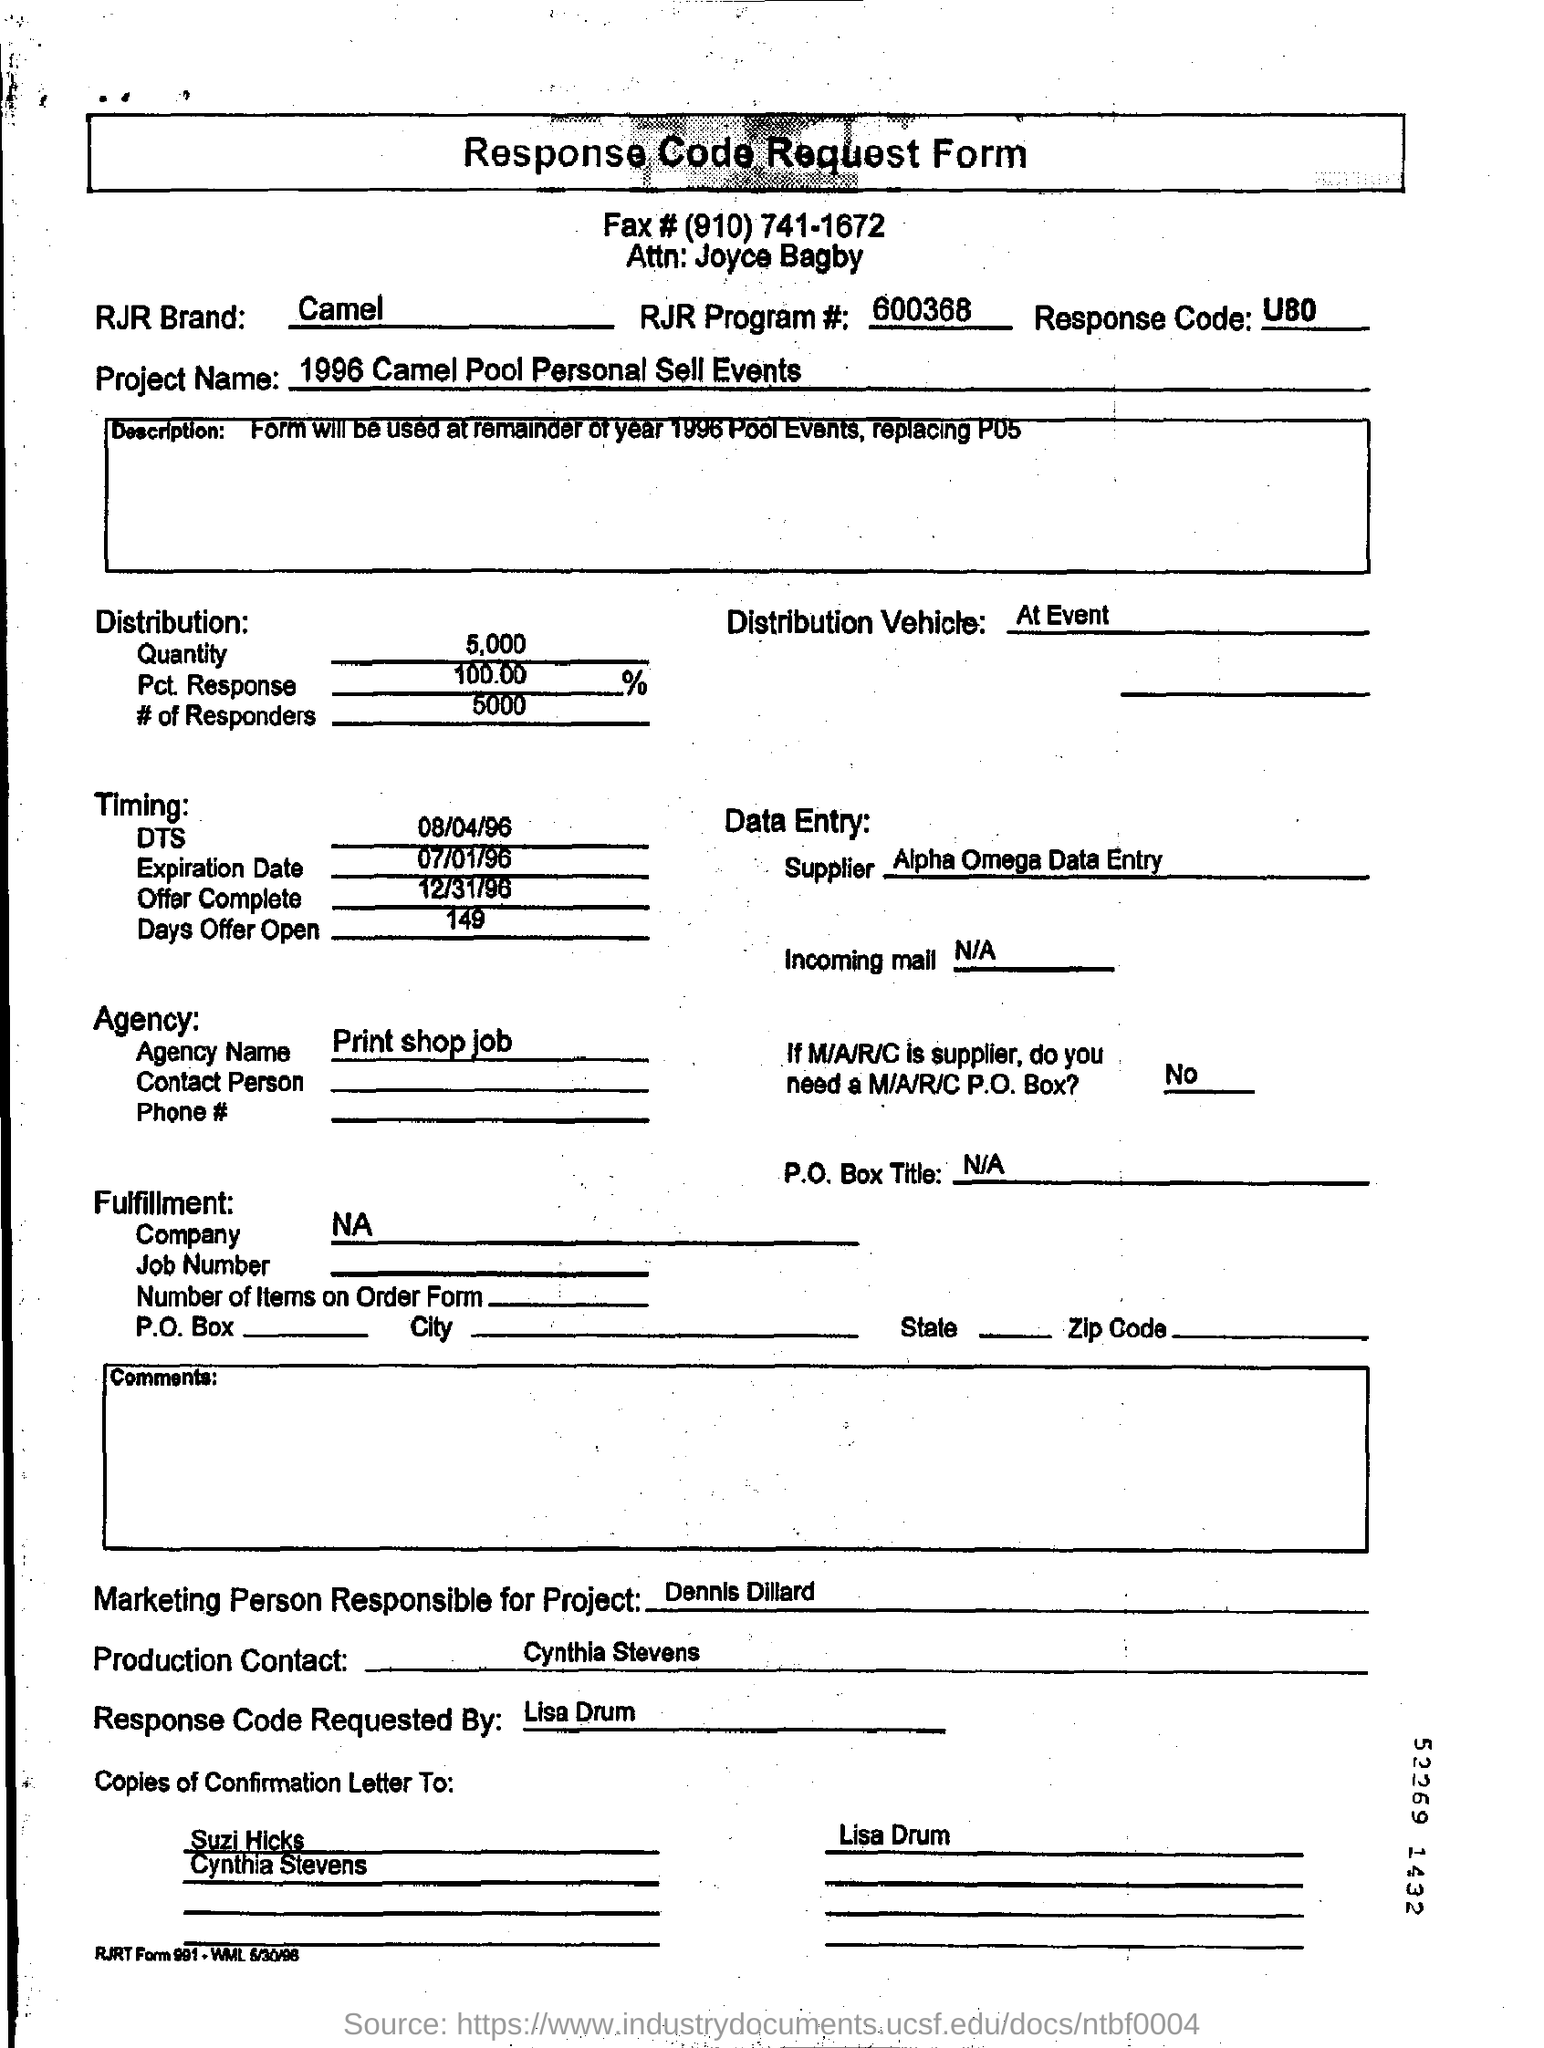What type of "Form" is this?
Your answer should be very brief. Response Code Request Form. What is the "Fax" number mentioned in the form?
Give a very brief answer. (910) 741-1672. What is RJR Brand?
Make the answer very short. Camel. What is the "RJR Program #" number given?
Offer a very short reply. 600368. What is the "Response Code" mentioned in the form?
Give a very brief answer. U80. What is the "Project Name"?
Offer a terse response. 1996 Camel Pool Personal Sell Events. What is the "Quantity" mentioned under "Distribution:"?
Provide a short and direct response. 5,000. What is the "Offer Complete" date mentioned under "Timing:"?
Keep it short and to the point. 12/31/96. Who is the "Marketing Person Responsible for Project"?
Provide a succinct answer. Dennis Dillard. Who is the "Production Contact"?
Keep it short and to the point. Cynthia Stevens. Response Code is requested by whom?
Your answer should be compact. Lisa Drum. What is the "Agency Name"?
Your answer should be very brief. Print shop job. 